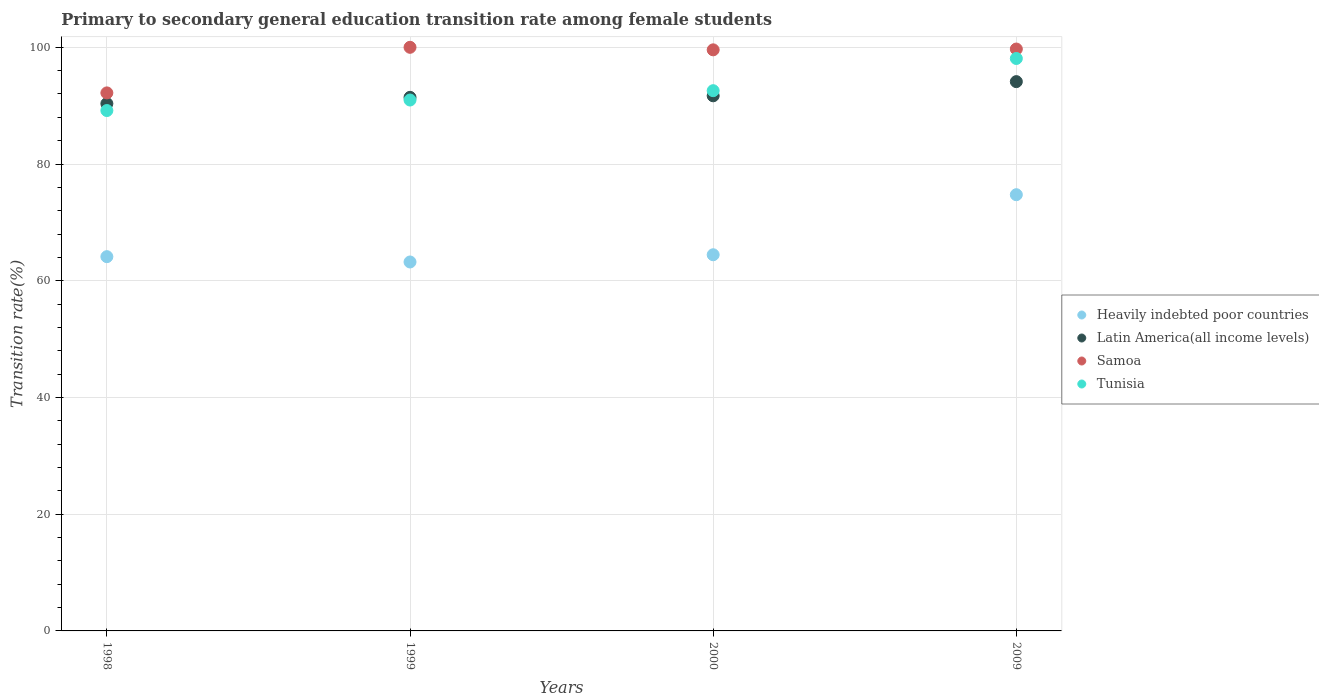How many different coloured dotlines are there?
Give a very brief answer. 4. Is the number of dotlines equal to the number of legend labels?
Offer a terse response. Yes. What is the transition rate in Samoa in 2000?
Keep it short and to the point. 99.57. Across all years, what is the maximum transition rate in Heavily indebted poor countries?
Your answer should be compact. 74.74. Across all years, what is the minimum transition rate in Heavily indebted poor countries?
Make the answer very short. 63.22. In which year was the transition rate in Tunisia minimum?
Make the answer very short. 1998. What is the total transition rate in Tunisia in the graph?
Provide a succinct answer. 370.79. What is the difference between the transition rate in Heavily indebted poor countries in 1999 and that in 2000?
Provide a short and direct response. -1.24. What is the difference between the transition rate in Tunisia in 1998 and the transition rate in Latin America(all income levels) in 2000?
Your response must be concise. -2.52. What is the average transition rate in Tunisia per year?
Offer a very short reply. 92.7. In the year 1999, what is the difference between the transition rate in Samoa and transition rate in Heavily indebted poor countries?
Offer a terse response. 36.78. What is the ratio of the transition rate in Samoa in 2000 to that in 2009?
Your response must be concise. 1. What is the difference between the highest and the second highest transition rate in Tunisia?
Your response must be concise. 5.52. What is the difference between the highest and the lowest transition rate in Latin America(all income levels)?
Keep it short and to the point. 3.77. Is it the case that in every year, the sum of the transition rate in Tunisia and transition rate in Latin America(all income levels)  is greater than the transition rate in Samoa?
Offer a very short reply. Yes. Is the transition rate in Tunisia strictly less than the transition rate in Samoa over the years?
Keep it short and to the point. Yes. How many dotlines are there?
Give a very brief answer. 4. What is the difference between two consecutive major ticks on the Y-axis?
Keep it short and to the point. 20. Does the graph contain any zero values?
Offer a terse response. No. Does the graph contain grids?
Your answer should be compact. Yes. What is the title of the graph?
Your response must be concise. Primary to secondary general education transition rate among female students. What is the label or title of the X-axis?
Your response must be concise. Years. What is the label or title of the Y-axis?
Give a very brief answer. Transition rate(%). What is the Transition rate(%) in Heavily indebted poor countries in 1998?
Your answer should be very brief. 64.13. What is the Transition rate(%) in Latin America(all income levels) in 1998?
Your response must be concise. 90.35. What is the Transition rate(%) of Samoa in 1998?
Your answer should be compact. 92.19. What is the Transition rate(%) in Tunisia in 1998?
Offer a very short reply. 89.17. What is the Transition rate(%) in Heavily indebted poor countries in 1999?
Offer a terse response. 63.22. What is the Transition rate(%) in Latin America(all income levels) in 1999?
Ensure brevity in your answer.  91.43. What is the Transition rate(%) of Samoa in 1999?
Provide a short and direct response. 100. What is the Transition rate(%) of Tunisia in 1999?
Your answer should be compact. 90.97. What is the Transition rate(%) of Heavily indebted poor countries in 2000?
Offer a terse response. 64.46. What is the Transition rate(%) of Latin America(all income levels) in 2000?
Your answer should be compact. 91.69. What is the Transition rate(%) in Samoa in 2000?
Keep it short and to the point. 99.57. What is the Transition rate(%) of Tunisia in 2000?
Offer a very short reply. 92.57. What is the Transition rate(%) of Heavily indebted poor countries in 2009?
Ensure brevity in your answer.  74.74. What is the Transition rate(%) in Latin America(all income levels) in 2009?
Ensure brevity in your answer.  94.12. What is the Transition rate(%) in Samoa in 2009?
Keep it short and to the point. 99.7. What is the Transition rate(%) of Tunisia in 2009?
Your response must be concise. 98.09. Across all years, what is the maximum Transition rate(%) in Heavily indebted poor countries?
Your answer should be very brief. 74.74. Across all years, what is the maximum Transition rate(%) of Latin America(all income levels)?
Make the answer very short. 94.12. Across all years, what is the maximum Transition rate(%) in Samoa?
Give a very brief answer. 100. Across all years, what is the maximum Transition rate(%) of Tunisia?
Provide a short and direct response. 98.09. Across all years, what is the minimum Transition rate(%) in Heavily indebted poor countries?
Provide a short and direct response. 63.22. Across all years, what is the minimum Transition rate(%) of Latin America(all income levels)?
Your answer should be compact. 90.35. Across all years, what is the minimum Transition rate(%) in Samoa?
Keep it short and to the point. 92.19. Across all years, what is the minimum Transition rate(%) in Tunisia?
Make the answer very short. 89.17. What is the total Transition rate(%) of Heavily indebted poor countries in the graph?
Your answer should be very brief. 266.55. What is the total Transition rate(%) of Latin America(all income levels) in the graph?
Keep it short and to the point. 367.59. What is the total Transition rate(%) of Samoa in the graph?
Offer a very short reply. 391.46. What is the total Transition rate(%) of Tunisia in the graph?
Offer a terse response. 370.79. What is the difference between the Transition rate(%) in Heavily indebted poor countries in 1998 and that in 1999?
Your response must be concise. 0.91. What is the difference between the Transition rate(%) of Latin America(all income levels) in 1998 and that in 1999?
Offer a terse response. -1.07. What is the difference between the Transition rate(%) of Samoa in 1998 and that in 1999?
Give a very brief answer. -7.81. What is the difference between the Transition rate(%) in Tunisia in 1998 and that in 1999?
Your answer should be compact. -1.8. What is the difference between the Transition rate(%) in Heavily indebted poor countries in 1998 and that in 2000?
Provide a succinct answer. -0.33. What is the difference between the Transition rate(%) of Latin America(all income levels) in 1998 and that in 2000?
Your response must be concise. -1.34. What is the difference between the Transition rate(%) in Samoa in 1998 and that in 2000?
Provide a short and direct response. -7.38. What is the difference between the Transition rate(%) of Tunisia in 1998 and that in 2000?
Your answer should be very brief. -3.4. What is the difference between the Transition rate(%) in Heavily indebted poor countries in 1998 and that in 2009?
Your answer should be compact. -10.62. What is the difference between the Transition rate(%) of Latin America(all income levels) in 1998 and that in 2009?
Your response must be concise. -3.77. What is the difference between the Transition rate(%) in Samoa in 1998 and that in 2009?
Your answer should be compact. -7.52. What is the difference between the Transition rate(%) in Tunisia in 1998 and that in 2009?
Your response must be concise. -8.92. What is the difference between the Transition rate(%) in Heavily indebted poor countries in 1999 and that in 2000?
Provide a succinct answer. -1.24. What is the difference between the Transition rate(%) of Latin America(all income levels) in 1999 and that in 2000?
Ensure brevity in your answer.  -0.26. What is the difference between the Transition rate(%) of Samoa in 1999 and that in 2000?
Your answer should be very brief. 0.43. What is the difference between the Transition rate(%) in Tunisia in 1999 and that in 2000?
Your answer should be very brief. -1.6. What is the difference between the Transition rate(%) in Heavily indebted poor countries in 1999 and that in 2009?
Your answer should be very brief. -11.53. What is the difference between the Transition rate(%) in Latin America(all income levels) in 1999 and that in 2009?
Keep it short and to the point. -2.69. What is the difference between the Transition rate(%) in Samoa in 1999 and that in 2009?
Your answer should be very brief. 0.3. What is the difference between the Transition rate(%) in Tunisia in 1999 and that in 2009?
Your answer should be compact. -7.12. What is the difference between the Transition rate(%) in Heavily indebted poor countries in 2000 and that in 2009?
Provide a short and direct response. -10.29. What is the difference between the Transition rate(%) of Latin America(all income levels) in 2000 and that in 2009?
Keep it short and to the point. -2.43. What is the difference between the Transition rate(%) of Samoa in 2000 and that in 2009?
Your answer should be compact. -0.14. What is the difference between the Transition rate(%) of Tunisia in 2000 and that in 2009?
Give a very brief answer. -5.52. What is the difference between the Transition rate(%) of Heavily indebted poor countries in 1998 and the Transition rate(%) of Latin America(all income levels) in 1999?
Offer a very short reply. -27.3. What is the difference between the Transition rate(%) of Heavily indebted poor countries in 1998 and the Transition rate(%) of Samoa in 1999?
Your response must be concise. -35.87. What is the difference between the Transition rate(%) of Heavily indebted poor countries in 1998 and the Transition rate(%) of Tunisia in 1999?
Make the answer very short. -26.84. What is the difference between the Transition rate(%) in Latin America(all income levels) in 1998 and the Transition rate(%) in Samoa in 1999?
Your response must be concise. -9.65. What is the difference between the Transition rate(%) in Latin America(all income levels) in 1998 and the Transition rate(%) in Tunisia in 1999?
Provide a short and direct response. -0.61. What is the difference between the Transition rate(%) in Samoa in 1998 and the Transition rate(%) in Tunisia in 1999?
Your response must be concise. 1.22. What is the difference between the Transition rate(%) of Heavily indebted poor countries in 1998 and the Transition rate(%) of Latin America(all income levels) in 2000?
Give a very brief answer. -27.56. What is the difference between the Transition rate(%) in Heavily indebted poor countries in 1998 and the Transition rate(%) in Samoa in 2000?
Offer a terse response. -35.44. What is the difference between the Transition rate(%) of Heavily indebted poor countries in 1998 and the Transition rate(%) of Tunisia in 2000?
Give a very brief answer. -28.44. What is the difference between the Transition rate(%) of Latin America(all income levels) in 1998 and the Transition rate(%) of Samoa in 2000?
Your answer should be very brief. -9.21. What is the difference between the Transition rate(%) of Latin America(all income levels) in 1998 and the Transition rate(%) of Tunisia in 2000?
Provide a succinct answer. -2.21. What is the difference between the Transition rate(%) in Samoa in 1998 and the Transition rate(%) in Tunisia in 2000?
Ensure brevity in your answer.  -0.38. What is the difference between the Transition rate(%) in Heavily indebted poor countries in 1998 and the Transition rate(%) in Latin America(all income levels) in 2009?
Keep it short and to the point. -29.99. What is the difference between the Transition rate(%) in Heavily indebted poor countries in 1998 and the Transition rate(%) in Samoa in 2009?
Provide a short and direct response. -35.58. What is the difference between the Transition rate(%) of Heavily indebted poor countries in 1998 and the Transition rate(%) of Tunisia in 2009?
Your answer should be compact. -33.96. What is the difference between the Transition rate(%) of Latin America(all income levels) in 1998 and the Transition rate(%) of Samoa in 2009?
Your answer should be compact. -9.35. What is the difference between the Transition rate(%) in Latin America(all income levels) in 1998 and the Transition rate(%) in Tunisia in 2009?
Your response must be concise. -7.73. What is the difference between the Transition rate(%) in Samoa in 1998 and the Transition rate(%) in Tunisia in 2009?
Offer a very short reply. -5.9. What is the difference between the Transition rate(%) of Heavily indebted poor countries in 1999 and the Transition rate(%) of Latin America(all income levels) in 2000?
Your answer should be very brief. -28.47. What is the difference between the Transition rate(%) in Heavily indebted poor countries in 1999 and the Transition rate(%) in Samoa in 2000?
Give a very brief answer. -36.35. What is the difference between the Transition rate(%) in Heavily indebted poor countries in 1999 and the Transition rate(%) in Tunisia in 2000?
Offer a very short reply. -29.35. What is the difference between the Transition rate(%) in Latin America(all income levels) in 1999 and the Transition rate(%) in Samoa in 2000?
Make the answer very short. -8.14. What is the difference between the Transition rate(%) of Latin America(all income levels) in 1999 and the Transition rate(%) of Tunisia in 2000?
Your answer should be compact. -1.14. What is the difference between the Transition rate(%) in Samoa in 1999 and the Transition rate(%) in Tunisia in 2000?
Ensure brevity in your answer.  7.43. What is the difference between the Transition rate(%) of Heavily indebted poor countries in 1999 and the Transition rate(%) of Latin America(all income levels) in 2009?
Your answer should be very brief. -30.9. What is the difference between the Transition rate(%) of Heavily indebted poor countries in 1999 and the Transition rate(%) of Samoa in 2009?
Offer a terse response. -36.49. What is the difference between the Transition rate(%) of Heavily indebted poor countries in 1999 and the Transition rate(%) of Tunisia in 2009?
Keep it short and to the point. -34.87. What is the difference between the Transition rate(%) in Latin America(all income levels) in 1999 and the Transition rate(%) in Samoa in 2009?
Provide a short and direct response. -8.28. What is the difference between the Transition rate(%) in Latin America(all income levels) in 1999 and the Transition rate(%) in Tunisia in 2009?
Ensure brevity in your answer.  -6.66. What is the difference between the Transition rate(%) in Samoa in 1999 and the Transition rate(%) in Tunisia in 2009?
Provide a succinct answer. 1.91. What is the difference between the Transition rate(%) of Heavily indebted poor countries in 2000 and the Transition rate(%) of Latin America(all income levels) in 2009?
Offer a terse response. -29.66. What is the difference between the Transition rate(%) in Heavily indebted poor countries in 2000 and the Transition rate(%) in Samoa in 2009?
Your response must be concise. -35.25. What is the difference between the Transition rate(%) of Heavily indebted poor countries in 2000 and the Transition rate(%) of Tunisia in 2009?
Offer a terse response. -33.63. What is the difference between the Transition rate(%) of Latin America(all income levels) in 2000 and the Transition rate(%) of Samoa in 2009?
Your answer should be compact. -8.01. What is the difference between the Transition rate(%) of Latin America(all income levels) in 2000 and the Transition rate(%) of Tunisia in 2009?
Provide a succinct answer. -6.4. What is the difference between the Transition rate(%) in Samoa in 2000 and the Transition rate(%) in Tunisia in 2009?
Make the answer very short. 1.48. What is the average Transition rate(%) in Heavily indebted poor countries per year?
Provide a succinct answer. 66.64. What is the average Transition rate(%) in Latin America(all income levels) per year?
Ensure brevity in your answer.  91.9. What is the average Transition rate(%) in Samoa per year?
Your response must be concise. 97.86. What is the average Transition rate(%) in Tunisia per year?
Provide a short and direct response. 92.7. In the year 1998, what is the difference between the Transition rate(%) of Heavily indebted poor countries and Transition rate(%) of Latin America(all income levels)?
Offer a terse response. -26.22. In the year 1998, what is the difference between the Transition rate(%) in Heavily indebted poor countries and Transition rate(%) in Samoa?
Your response must be concise. -28.06. In the year 1998, what is the difference between the Transition rate(%) of Heavily indebted poor countries and Transition rate(%) of Tunisia?
Make the answer very short. -25.04. In the year 1998, what is the difference between the Transition rate(%) of Latin America(all income levels) and Transition rate(%) of Samoa?
Offer a terse response. -1.84. In the year 1998, what is the difference between the Transition rate(%) of Latin America(all income levels) and Transition rate(%) of Tunisia?
Make the answer very short. 1.19. In the year 1998, what is the difference between the Transition rate(%) in Samoa and Transition rate(%) in Tunisia?
Ensure brevity in your answer.  3.02. In the year 1999, what is the difference between the Transition rate(%) in Heavily indebted poor countries and Transition rate(%) in Latin America(all income levels)?
Offer a very short reply. -28.21. In the year 1999, what is the difference between the Transition rate(%) in Heavily indebted poor countries and Transition rate(%) in Samoa?
Provide a succinct answer. -36.78. In the year 1999, what is the difference between the Transition rate(%) of Heavily indebted poor countries and Transition rate(%) of Tunisia?
Offer a terse response. -27.75. In the year 1999, what is the difference between the Transition rate(%) in Latin America(all income levels) and Transition rate(%) in Samoa?
Offer a very short reply. -8.57. In the year 1999, what is the difference between the Transition rate(%) of Latin America(all income levels) and Transition rate(%) of Tunisia?
Keep it short and to the point. 0.46. In the year 1999, what is the difference between the Transition rate(%) in Samoa and Transition rate(%) in Tunisia?
Keep it short and to the point. 9.03. In the year 2000, what is the difference between the Transition rate(%) of Heavily indebted poor countries and Transition rate(%) of Latin America(all income levels)?
Your response must be concise. -27.23. In the year 2000, what is the difference between the Transition rate(%) of Heavily indebted poor countries and Transition rate(%) of Samoa?
Provide a succinct answer. -35.11. In the year 2000, what is the difference between the Transition rate(%) of Heavily indebted poor countries and Transition rate(%) of Tunisia?
Offer a very short reply. -28.11. In the year 2000, what is the difference between the Transition rate(%) of Latin America(all income levels) and Transition rate(%) of Samoa?
Your answer should be compact. -7.88. In the year 2000, what is the difference between the Transition rate(%) of Latin America(all income levels) and Transition rate(%) of Tunisia?
Ensure brevity in your answer.  -0.88. In the year 2000, what is the difference between the Transition rate(%) of Samoa and Transition rate(%) of Tunisia?
Ensure brevity in your answer.  7. In the year 2009, what is the difference between the Transition rate(%) of Heavily indebted poor countries and Transition rate(%) of Latin America(all income levels)?
Your answer should be compact. -19.37. In the year 2009, what is the difference between the Transition rate(%) in Heavily indebted poor countries and Transition rate(%) in Samoa?
Keep it short and to the point. -24.96. In the year 2009, what is the difference between the Transition rate(%) in Heavily indebted poor countries and Transition rate(%) in Tunisia?
Your answer should be compact. -23.34. In the year 2009, what is the difference between the Transition rate(%) in Latin America(all income levels) and Transition rate(%) in Samoa?
Ensure brevity in your answer.  -5.59. In the year 2009, what is the difference between the Transition rate(%) of Latin America(all income levels) and Transition rate(%) of Tunisia?
Give a very brief answer. -3.97. In the year 2009, what is the difference between the Transition rate(%) of Samoa and Transition rate(%) of Tunisia?
Ensure brevity in your answer.  1.62. What is the ratio of the Transition rate(%) of Heavily indebted poor countries in 1998 to that in 1999?
Provide a succinct answer. 1.01. What is the ratio of the Transition rate(%) in Latin America(all income levels) in 1998 to that in 1999?
Your answer should be very brief. 0.99. What is the ratio of the Transition rate(%) of Samoa in 1998 to that in 1999?
Make the answer very short. 0.92. What is the ratio of the Transition rate(%) in Tunisia in 1998 to that in 1999?
Your answer should be very brief. 0.98. What is the ratio of the Transition rate(%) in Latin America(all income levels) in 1998 to that in 2000?
Make the answer very short. 0.99. What is the ratio of the Transition rate(%) in Samoa in 1998 to that in 2000?
Your answer should be compact. 0.93. What is the ratio of the Transition rate(%) of Tunisia in 1998 to that in 2000?
Make the answer very short. 0.96. What is the ratio of the Transition rate(%) in Heavily indebted poor countries in 1998 to that in 2009?
Keep it short and to the point. 0.86. What is the ratio of the Transition rate(%) in Latin America(all income levels) in 1998 to that in 2009?
Your answer should be compact. 0.96. What is the ratio of the Transition rate(%) of Samoa in 1998 to that in 2009?
Make the answer very short. 0.92. What is the ratio of the Transition rate(%) in Tunisia in 1998 to that in 2009?
Make the answer very short. 0.91. What is the ratio of the Transition rate(%) in Heavily indebted poor countries in 1999 to that in 2000?
Your answer should be very brief. 0.98. What is the ratio of the Transition rate(%) in Tunisia in 1999 to that in 2000?
Your answer should be very brief. 0.98. What is the ratio of the Transition rate(%) in Heavily indebted poor countries in 1999 to that in 2009?
Your answer should be very brief. 0.85. What is the ratio of the Transition rate(%) in Latin America(all income levels) in 1999 to that in 2009?
Provide a succinct answer. 0.97. What is the ratio of the Transition rate(%) of Tunisia in 1999 to that in 2009?
Your answer should be compact. 0.93. What is the ratio of the Transition rate(%) of Heavily indebted poor countries in 2000 to that in 2009?
Your answer should be compact. 0.86. What is the ratio of the Transition rate(%) of Latin America(all income levels) in 2000 to that in 2009?
Your answer should be compact. 0.97. What is the ratio of the Transition rate(%) in Tunisia in 2000 to that in 2009?
Your answer should be very brief. 0.94. What is the difference between the highest and the second highest Transition rate(%) of Heavily indebted poor countries?
Provide a short and direct response. 10.29. What is the difference between the highest and the second highest Transition rate(%) in Latin America(all income levels)?
Offer a terse response. 2.43. What is the difference between the highest and the second highest Transition rate(%) in Samoa?
Give a very brief answer. 0.3. What is the difference between the highest and the second highest Transition rate(%) in Tunisia?
Your response must be concise. 5.52. What is the difference between the highest and the lowest Transition rate(%) of Heavily indebted poor countries?
Offer a terse response. 11.53. What is the difference between the highest and the lowest Transition rate(%) of Latin America(all income levels)?
Give a very brief answer. 3.77. What is the difference between the highest and the lowest Transition rate(%) of Samoa?
Offer a very short reply. 7.81. What is the difference between the highest and the lowest Transition rate(%) of Tunisia?
Ensure brevity in your answer.  8.92. 